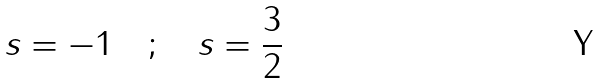Convert formula to latex. <formula><loc_0><loc_0><loc_500><loc_500>s = - 1 \quad ; \quad s = \frac { 3 } { 2 }</formula> 